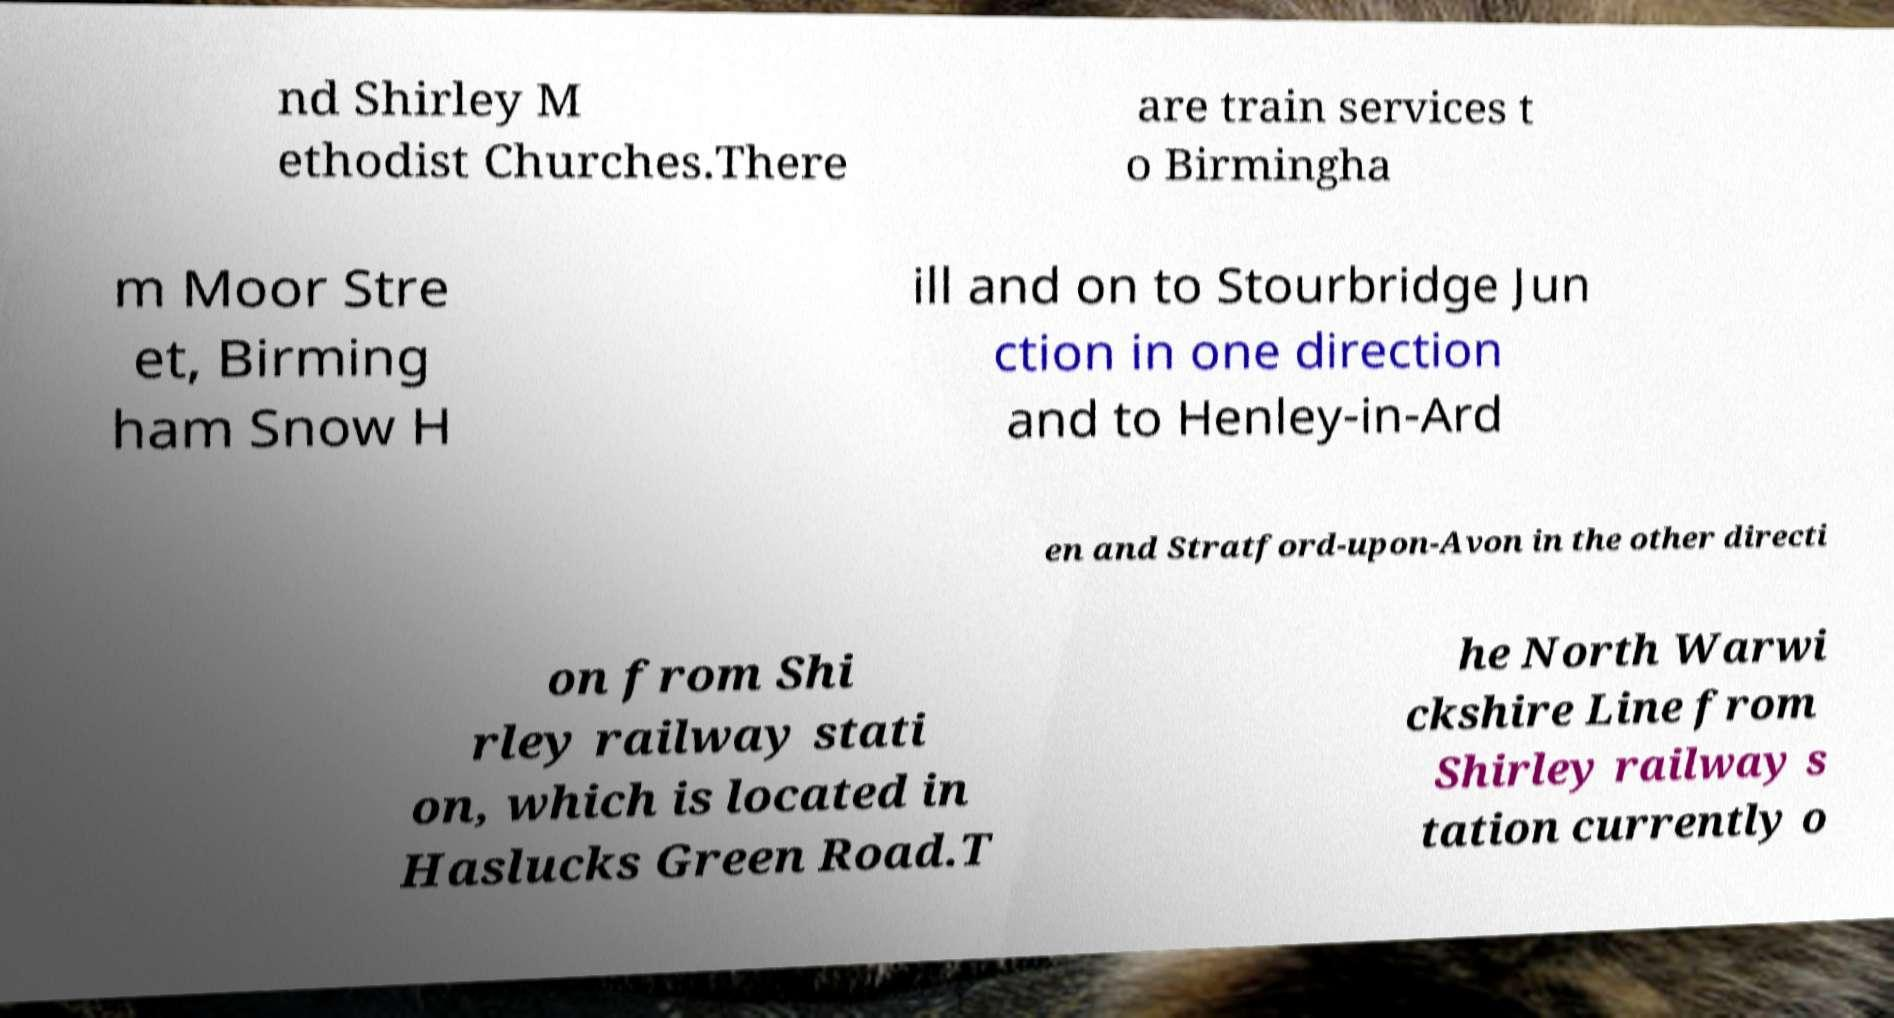Could you extract and type out the text from this image? nd Shirley M ethodist Churches.There are train services t o Birmingha m Moor Stre et, Birming ham Snow H ill and on to Stourbridge Jun ction in one direction and to Henley-in-Ard en and Stratford-upon-Avon in the other directi on from Shi rley railway stati on, which is located in Haslucks Green Road.T he North Warwi ckshire Line from Shirley railway s tation currently o 